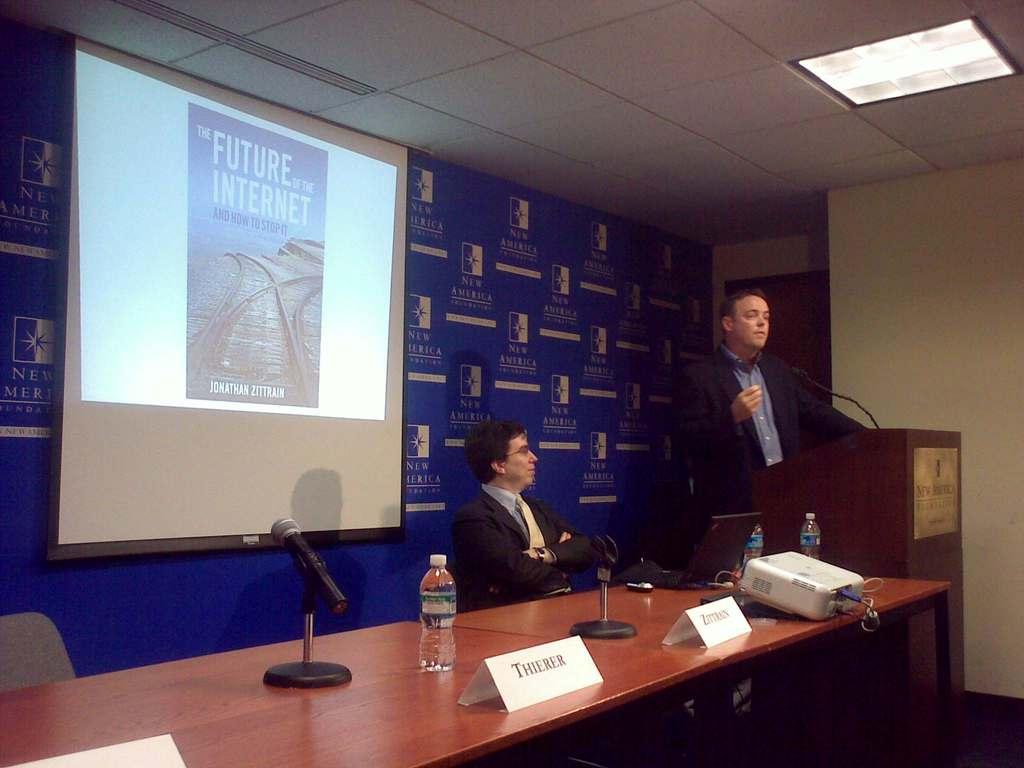What is the book called?
Offer a very short reply. The future of the internet. Who wrote the book on screen?
Offer a terse response. Jonathan zittrain. 